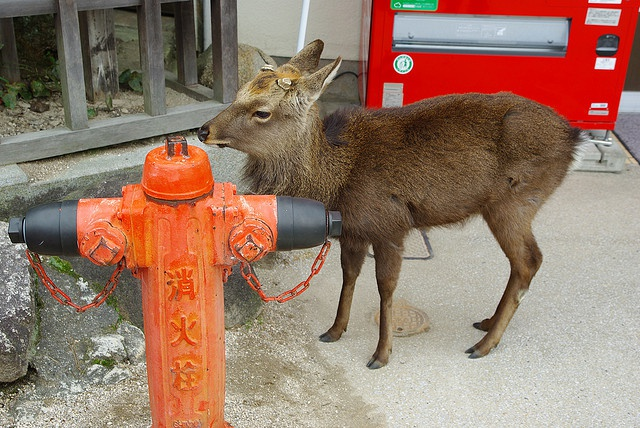Describe the objects in this image and their specific colors. I can see sheep in gray, maroon, and black tones, fire hydrant in gray, red, and salmon tones, parking meter in gray, red, lightgray, and darkgray tones, and sheep in gray, darkgray, and black tones in this image. 